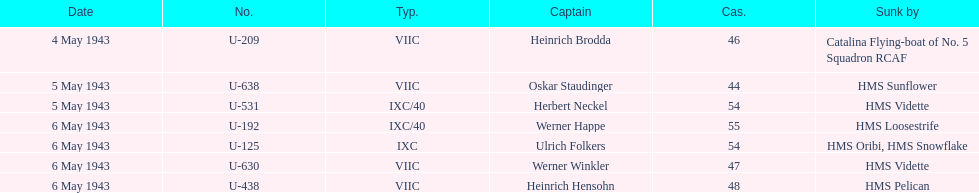How many more casualties occurred on may 6 compared to may 4? 158. 